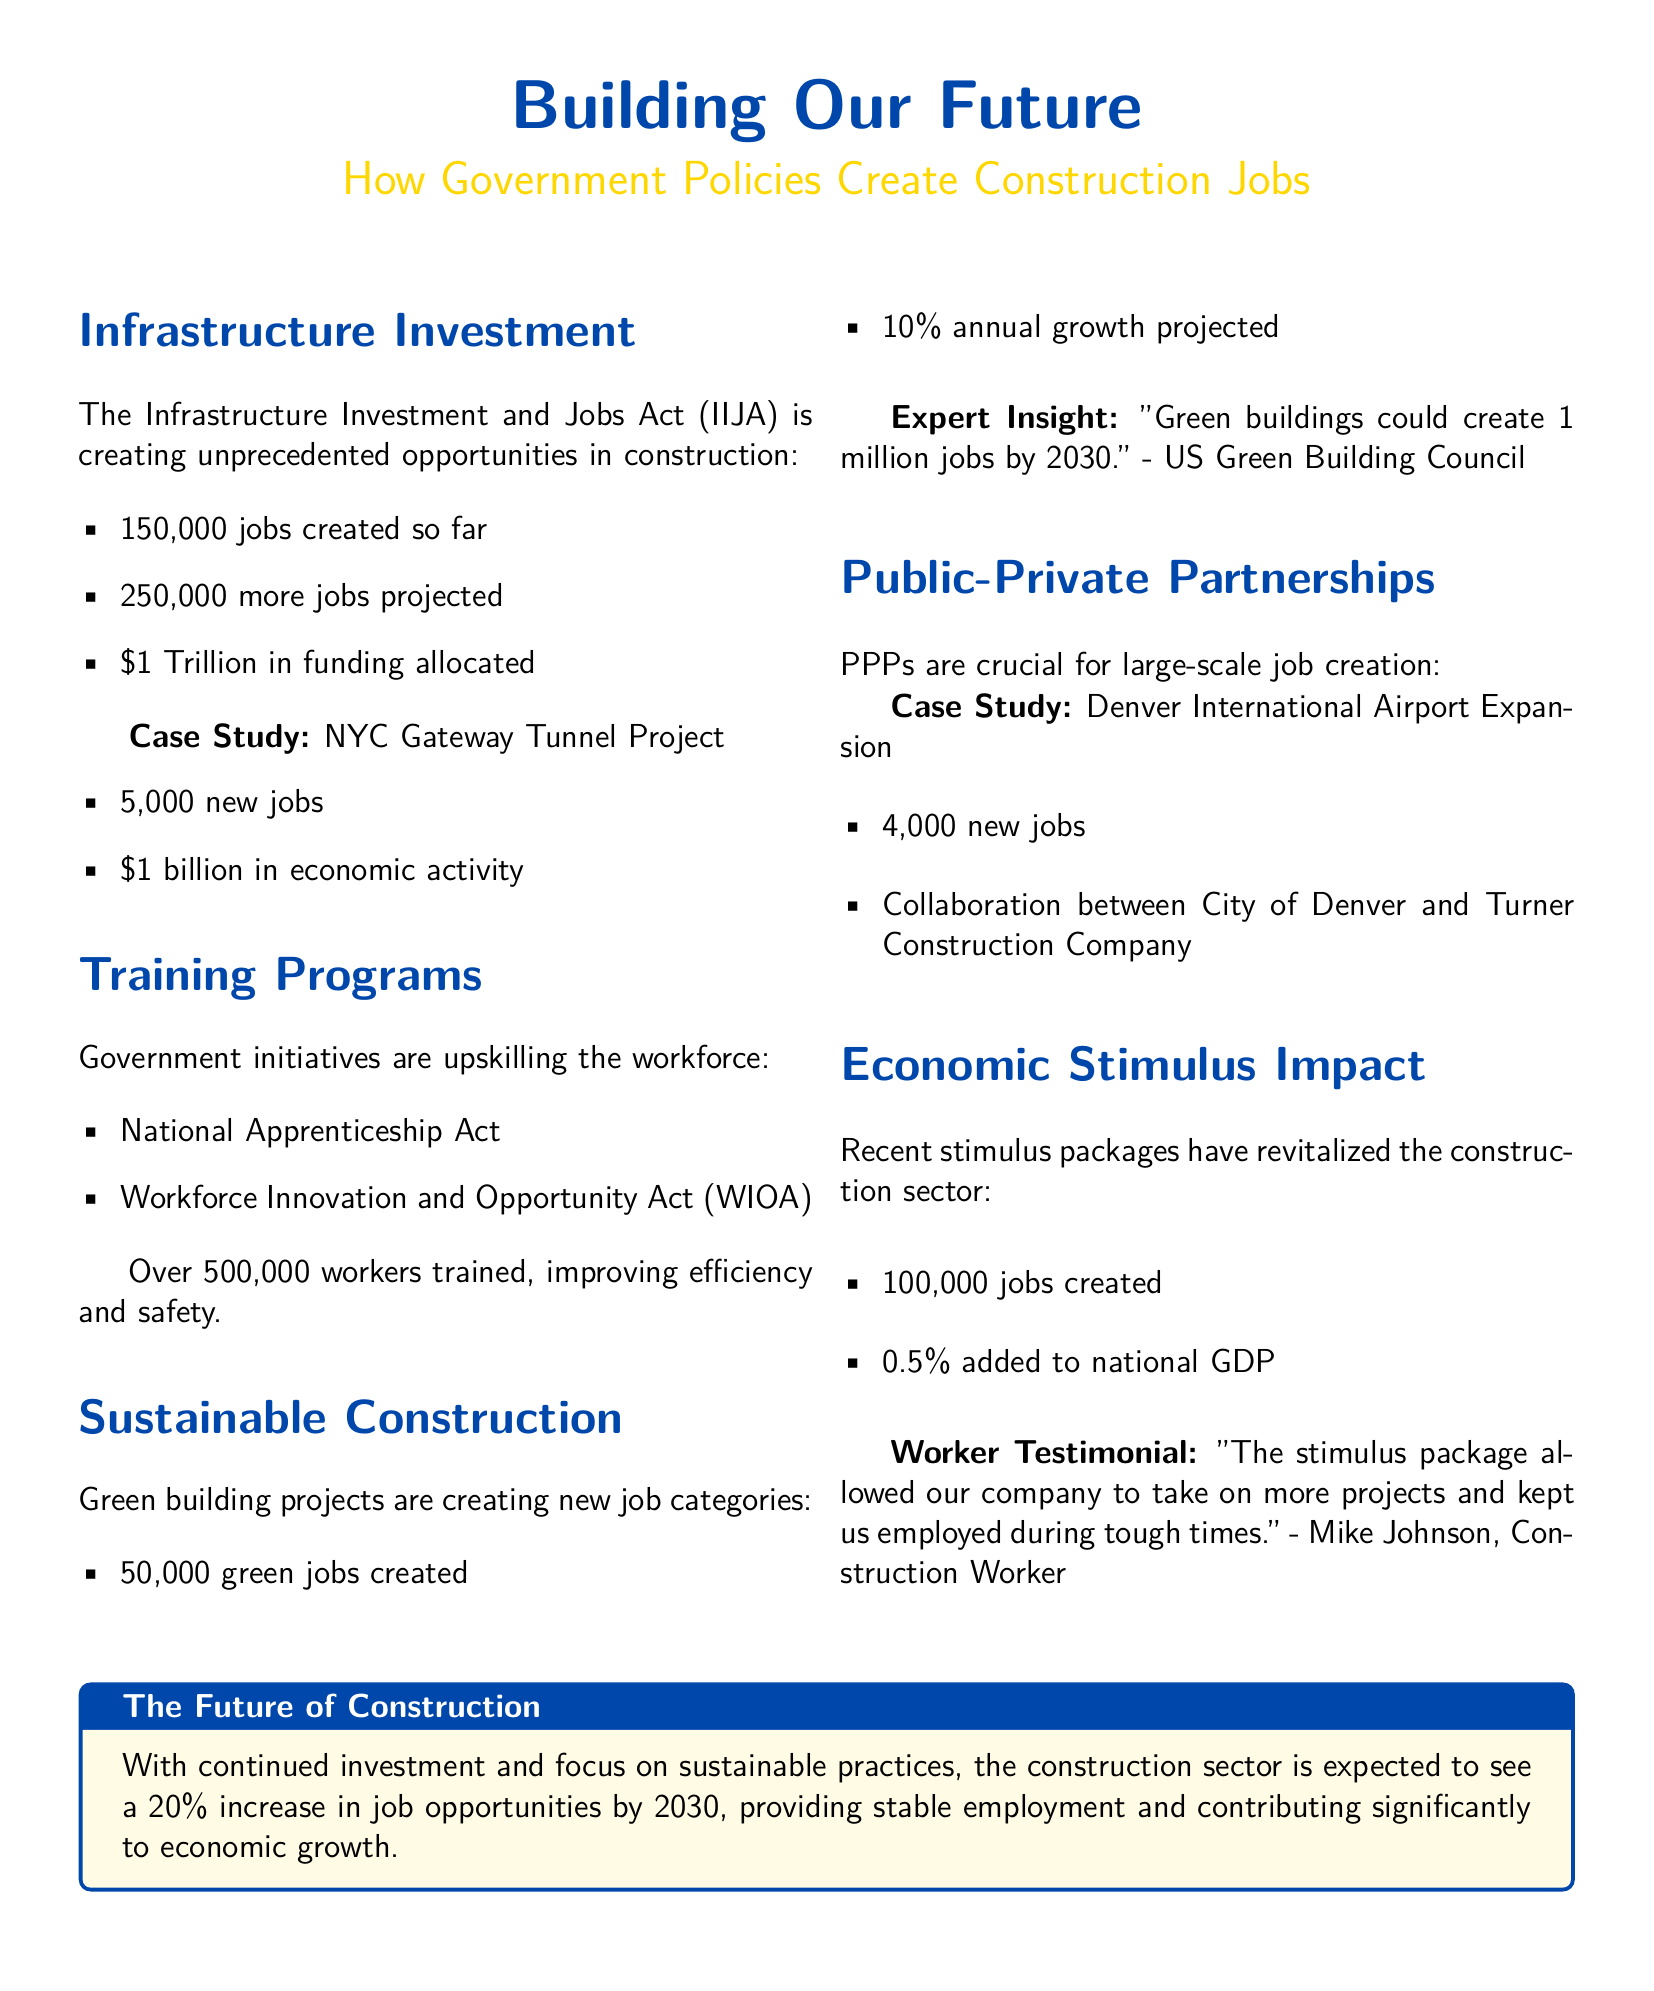What is the total job creation due to the Infrastructure Investment and Jobs Act? The total jobs created so far are listed as 150,000, with a projection of an additional 250,000 jobs.
Answer: 150,000 How much funding is allocated by the Infrastructure Investment and Jobs Act? The document states that \$1 Trillion in funding is allocated for infrastructure projects.
Answer: \$1 Trillion What percentage of annual growth is projected for green jobs? The projected annual growth for green jobs is specified as 10%.
Answer: 10% How many workers have been trained through government initiatives? The document indicates that over 500,000 workers have been trained.
Answer: 500,000 What impact did recent stimulus packages have on national GDP? According to the document, the stimulus packages added 0.5% to national GDP.
Answer: 0.5% What is the job creation number for the Denver International Airport Expansion? The document states that the Denver International Airport Expansion has created 4,000 new jobs.
Answer: 4,000 What is the projected increase in job opportunities by 2030 in the construction sector? The future job opportunities in the construction sector are expected to increase by 20% by 2030.
Answer: 20% What is the case study mentioned for infrastructure job creation? The NYC Gateway Tunnel Project is highlighted as a case study for job creation in the document.
Answer: NYC Gateway Tunnel Project What success story is shared in the economic stimulus section? The testimonial from Mike Johnson reflects the positive impact of the stimulus on employment during tough times.
Answer: Mike Johnson, Construction Worker 